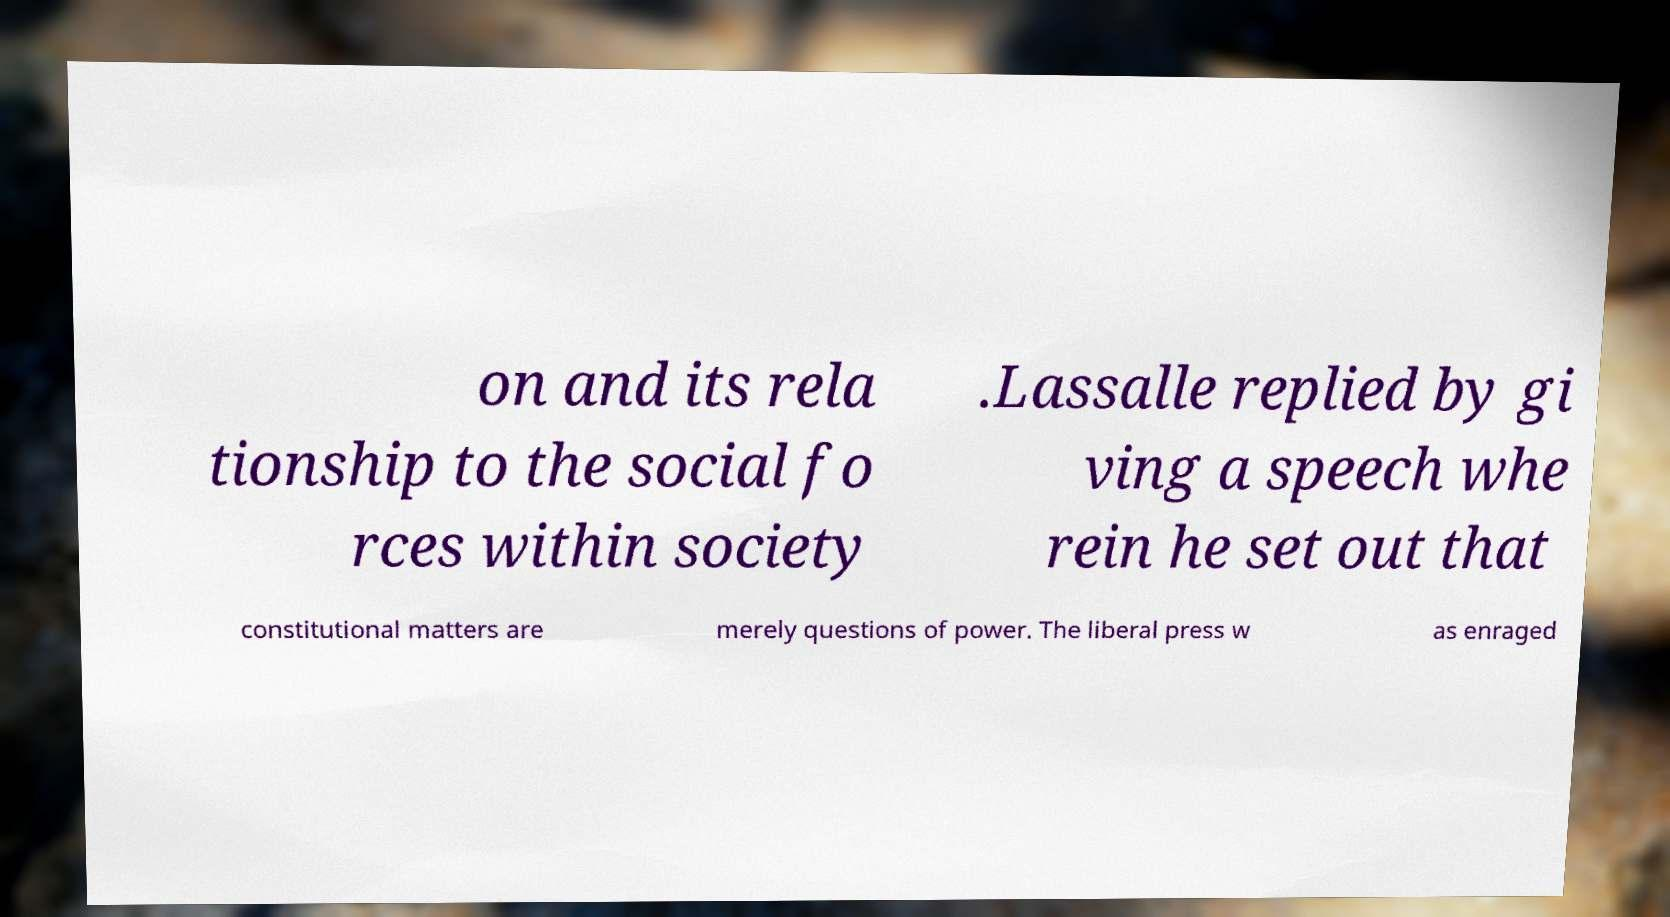Please read and relay the text visible in this image. What does it say? on and its rela tionship to the social fo rces within society .Lassalle replied by gi ving a speech whe rein he set out that constitutional matters are merely questions of power. The liberal press w as enraged 